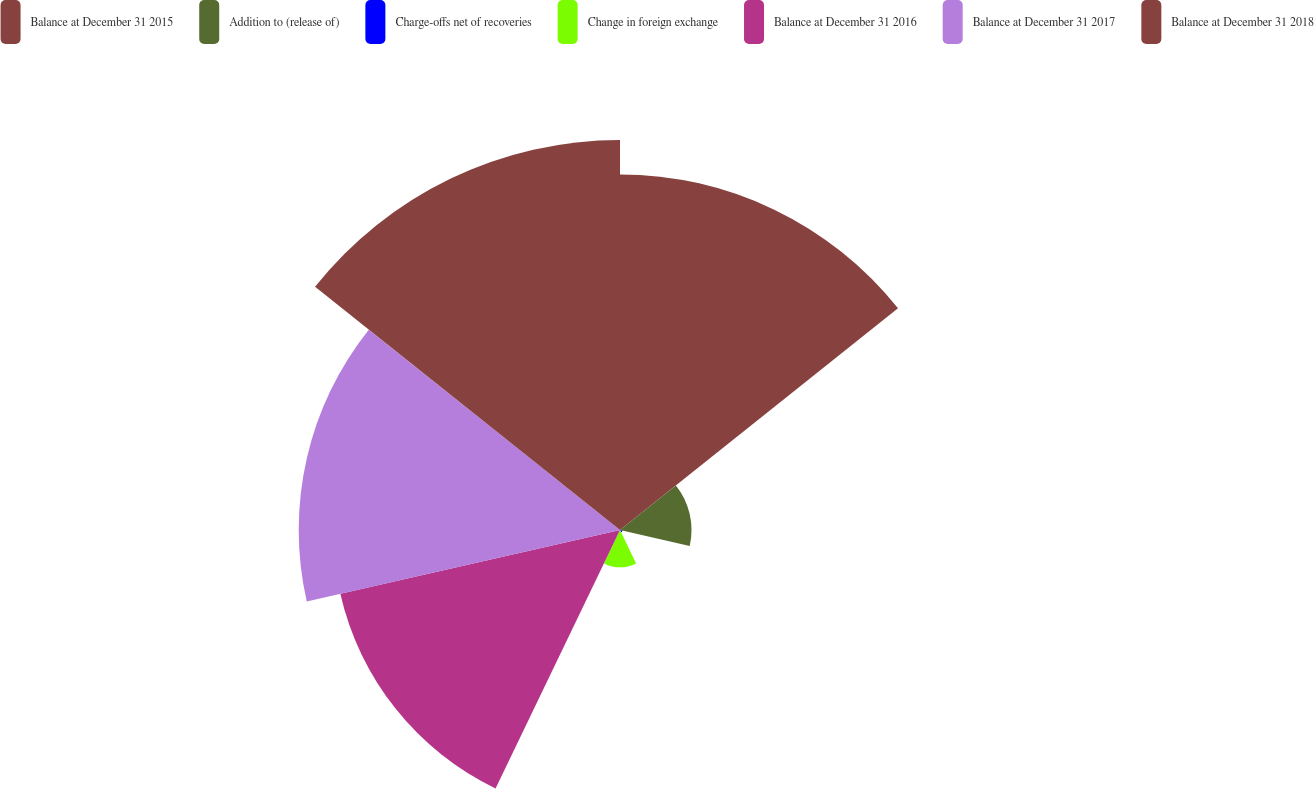Convert chart to OTSL. <chart><loc_0><loc_0><loc_500><loc_500><pie_chart><fcel>Balance at December 31 2015<fcel>Addition to (release of)<fcel>Charge-offs net of recoveries<fcel>Change in foreign exchange<fcel>Balance at December 31 2016<fcel>Balance at December 31 2017<fcel>Balance at December 31 2018<nl><fcel>24.27%<fcel>4.88%<fcel>0.18%<fcel>2.53%<fcel>19.58%<fcel>21.93%<fcel>26.62%<nl></chart> 